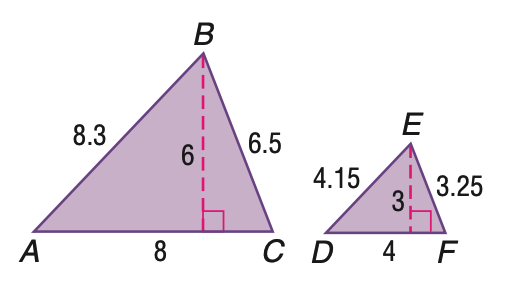Question: Triangle A B C is similar to triangle D E F. Find the scale factor.
Choices:
A. \frac { 1 } { 2 }
B. \frac { 1 } { 1 }
C. \frac { 2 } { 1 }
D. \frac { 4 } { 1 }
Answer with the letter. Answer: C 